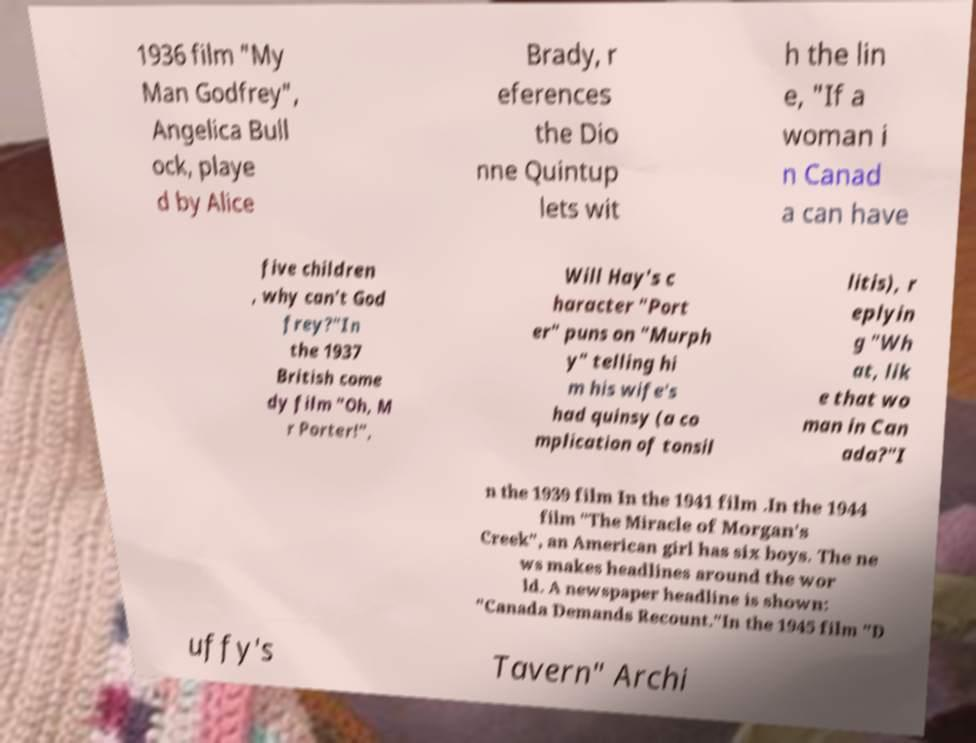For documentation purposes, I need the text within this image transcribed. Could you provide that? 1936 film "My Man Godfrey", Angelica Bull ock, playe d by Alice Brady, r eferences the Dio nne Quintup lets wit h the lin e, "If a woman i n Canad a can have five children , why can't God frey?"In the 1937 British come dy film "Oh, M r Porter!", Will Hay's c haracter "Port er" puns on "Murph y" telling hi m his wife's had quinsy (a co mplication of tonsil litis), r eplyin g "Wh at, lik e that wo man in Can ada?"I n the 1939 film In the 1941 film .In the 1944 film "The Miracle of Morgan's Creek", an American girl has six boys. The ne ws makes headlines around the wor ld. A newspaper headline is shown: "Canada Demands Recount."In the 1945 film "D uffy's Tavern" Archi 